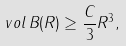<formula> <loc_0><loc_0><loc_500><loc_500>\ v o l \, B ( R ) \geq \frac { C } { 3 } R ^ { 3 } ,</formula> 